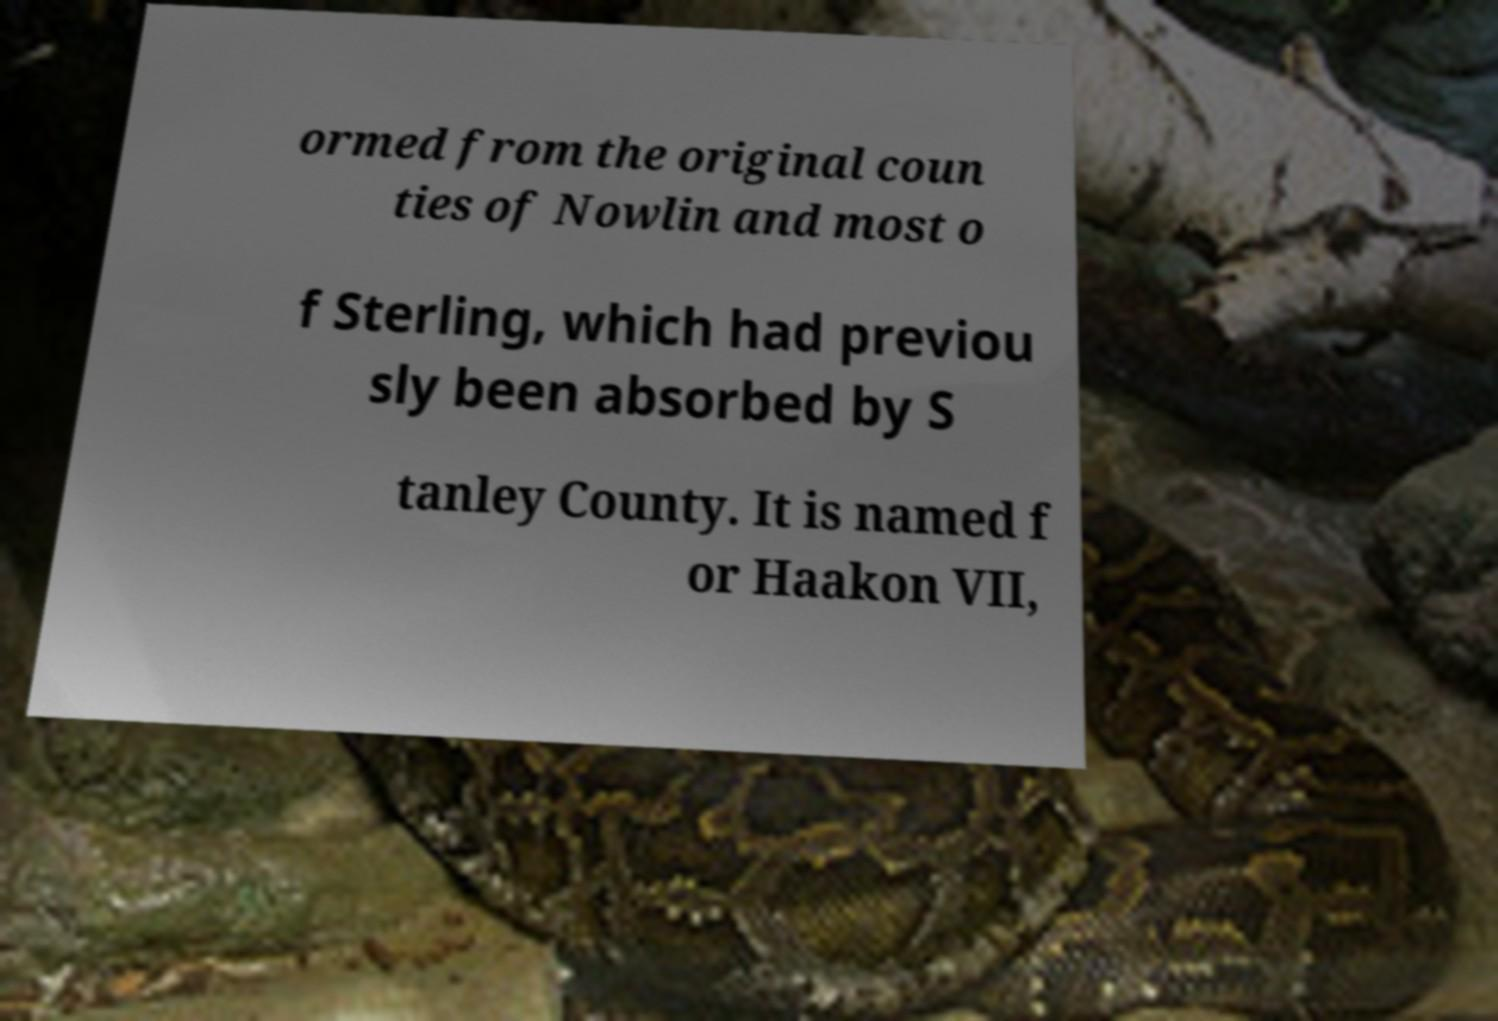For documentation purposes, I need the text within this image transcribed. Could you provide that? ormed from the original coun ties of Nowlin and most o f Sterling, which had previou sly been absorbed by S tanley County. It is named f or Haakon VII, 